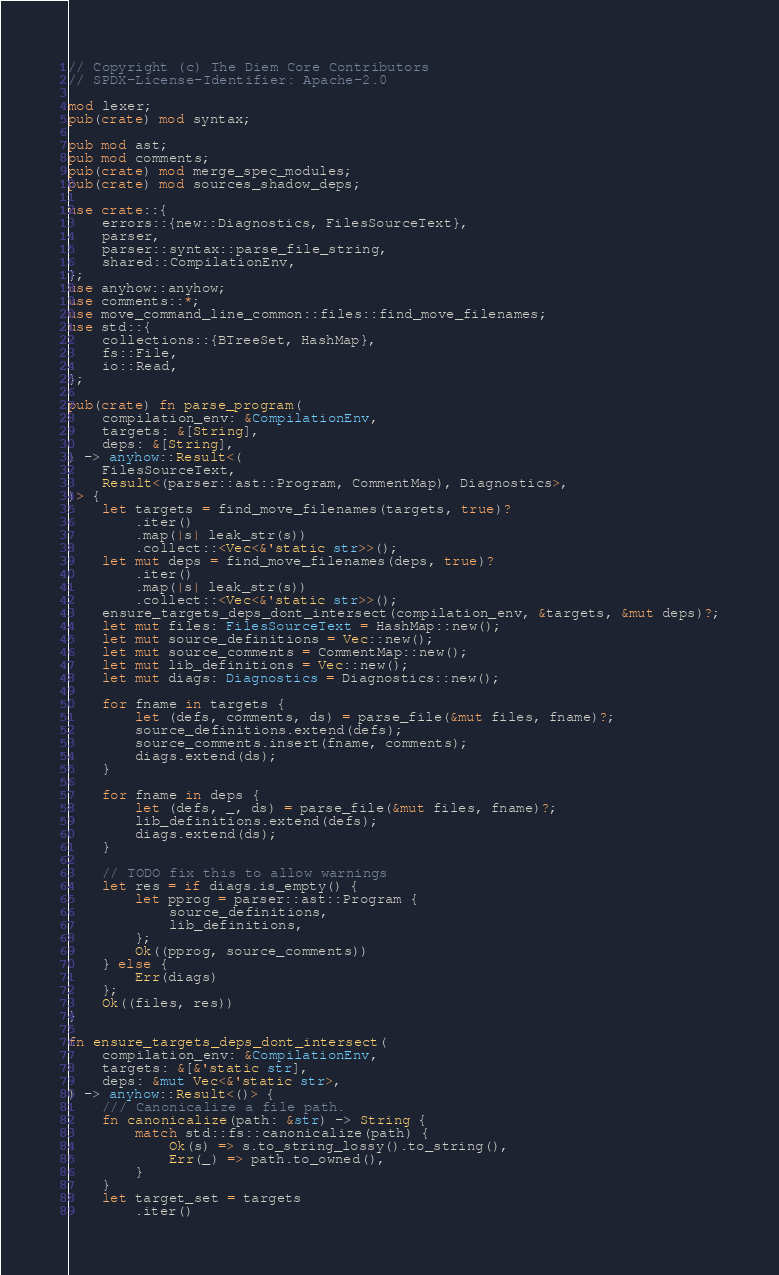Convert code to text. <code><loc_0><loc_0><loc_500><loc_500><_Rust_>// Copyright (c) The Diem Core Contributors
// SPDX-License-Identifier: Apache-2.0

mod lexer;
pub(crate) mod syntax;

pub mod ast;
pub mod comments;
pub(crate) mod merge_spec_modules;
pub(crate) mod sources_shadow_deps;

use crate::{
    errors::{new::Diagnostics, FilesSourceText},
    parser,
    parser::syntax::parse_file_string,
    shared::CompilationEnv,
};
use anyhow::anyhow;
use comments::*;
use move_command_line_common::files::find_move_filenames;
use std::{
    collections::{BTreeSet, HashMap},
    fs::File,
    io::Read,
};

pub(crate) fn parse_program(
    compilation_env: &CompilationEnv,
    targets: &[String],
    deps: &[String],
) -> anyhow::Result<(
    FilesSourceText,
    Result<(parser::ast::Program, CommentMap), Diagnostics>,
)> {
    let targets = find_move_filenames(targets, true)?
        .iter()
        .map(|s| leak_str(s))
        .collect::<Vec<&'static str>>();
    let mut deps = find_move_filenames(deps, true)?
        .iter()
        .map(|s| leak_str(s))
        .collect::<Vec<&'static str>>();
    ensure_targets_deps_dont_intersect(compilation_env, &targets, &mut deps)?;
    let mut files: FilesSourceText = HashMap::new();
    let mut source_definitions = Vec::new();
    let mut source_comments = CommentMap::new();
    let mut lib_definitions = Vec::new();
    let mut diags: Diagnostics = Diagnostics::new();

    for fname in targets {
        let (defs, comments, ds) = parse_file(&mut files, fname)?;
        source_definitions.extend(defs);
        source_comments.insert(fname, comments);
        diags.extend(ds);
    }

    for fname in deps {
        let (defs, _, ds) = parse_file(&mut files, fname)?;
        lib_definitions.extend(defs);
        diags.extend(ds);
    }

    // TODO fix this to allow warnings
    let res = if diags.is_empty() {
        let pprog = parser::ast::Program {
            source_definitions,
            lib_definitions,
        };
        Ok((pprog, source_comments))
    } else {
        Err(diags)
    };
    Ok((files, res))
}

fn ensure_targets_deps_dont_intersect(
    compilation_env: &CompilationEnv,
    targets: &[&'static str],
    deps: &mut Vec<&'static str>,
) -> anyhow::Result<()> {
    /// Canonicalize a file path.
    fn canonicalize(path: &str) -> String {
        match std::fs::canonicalize(path) {
            Ok(s) => s.to_string_lossy().to_string(),
            Err(_) => path.to_owned(),
        }
    }
    let target_set = targets
        .iter()</code> 